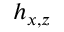Convert formula to latex. <formula><loc_0><loc_0><loc_500><loc_500>h _ { x , z }</formula> 